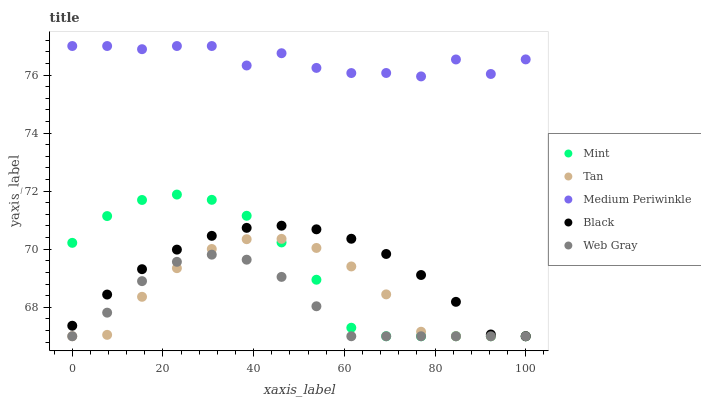Does Web Gray have the minimum area under the curve?
Answer yes or no. Yes. Does Medium Periwinkle have the maximum area under the curve?
Answer yes or no. Yes. Does Tan have the minimum area under the curve?
Answer yes or no. No. Does Tan have the maximum area under the curve?
Answer yes or no. No. Is Black the smoothest?
Answer yes or no. Yes. Is Medium Periwinkle the roughest?
Answer yes or no. Yes. Is Tan the smoothest?
Answer yes or no. No. Is Tan the roughest?
Answer yes or no. No. Does Tan have the lowest value?
Answer yes or no. Yes. Does Medium Periwinkle have the highest value?
Answer yes or no. Yes. Does Tan have the highest value?
Answer yes or no. No. Is Web Gray less than Medium Periwinkle?
Answer yes or no. Yes. Is Medium Periwinkle greater than Mint?
Answer yes or no. Yes. Does Black intersect Mint?
Answer yes or no. Yes. Is Black less than Mint?
Answer yes or no. No. Is Black greater than Mint?
Answer yes or no. No. Does Web Gray intersect Medium Periwinkle?
Answer yes or no. No. 